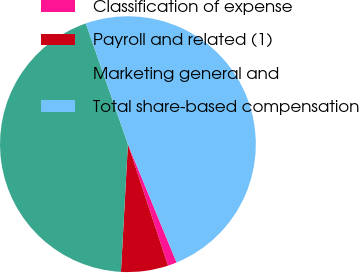Convert chart to OTSL. <chart><loc_0><loc_0><loc_500><loc_500><pie_chart><fcel>Classification of expense<fcel>Payroll and related (1)<fcel>Marketing general and<fcel>Total share-based compensation<nl><fcel>1.14%<fcel>5.94%<fcel>43.79%<fcel>49.13%<nl></chart> 